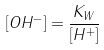Convert formula to latex. <formula><loc_0><loc_0><loc_500><loc_500>[ O H ^ { - } ] = \frac { K _ { W } } { [ H ^ { + } ] }</formula> 